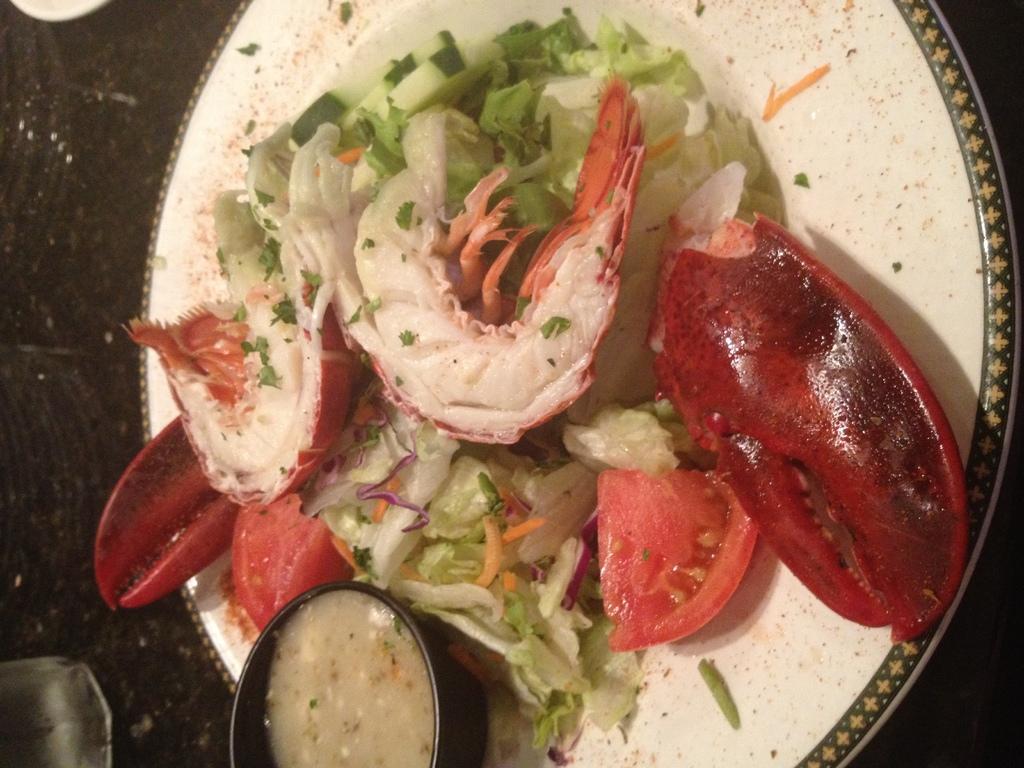How would you summarize this image in a sentence or two? In this image there is chopped tomatoes, green salad and some other food items are placed on a plate, the plate is on top of a table. 